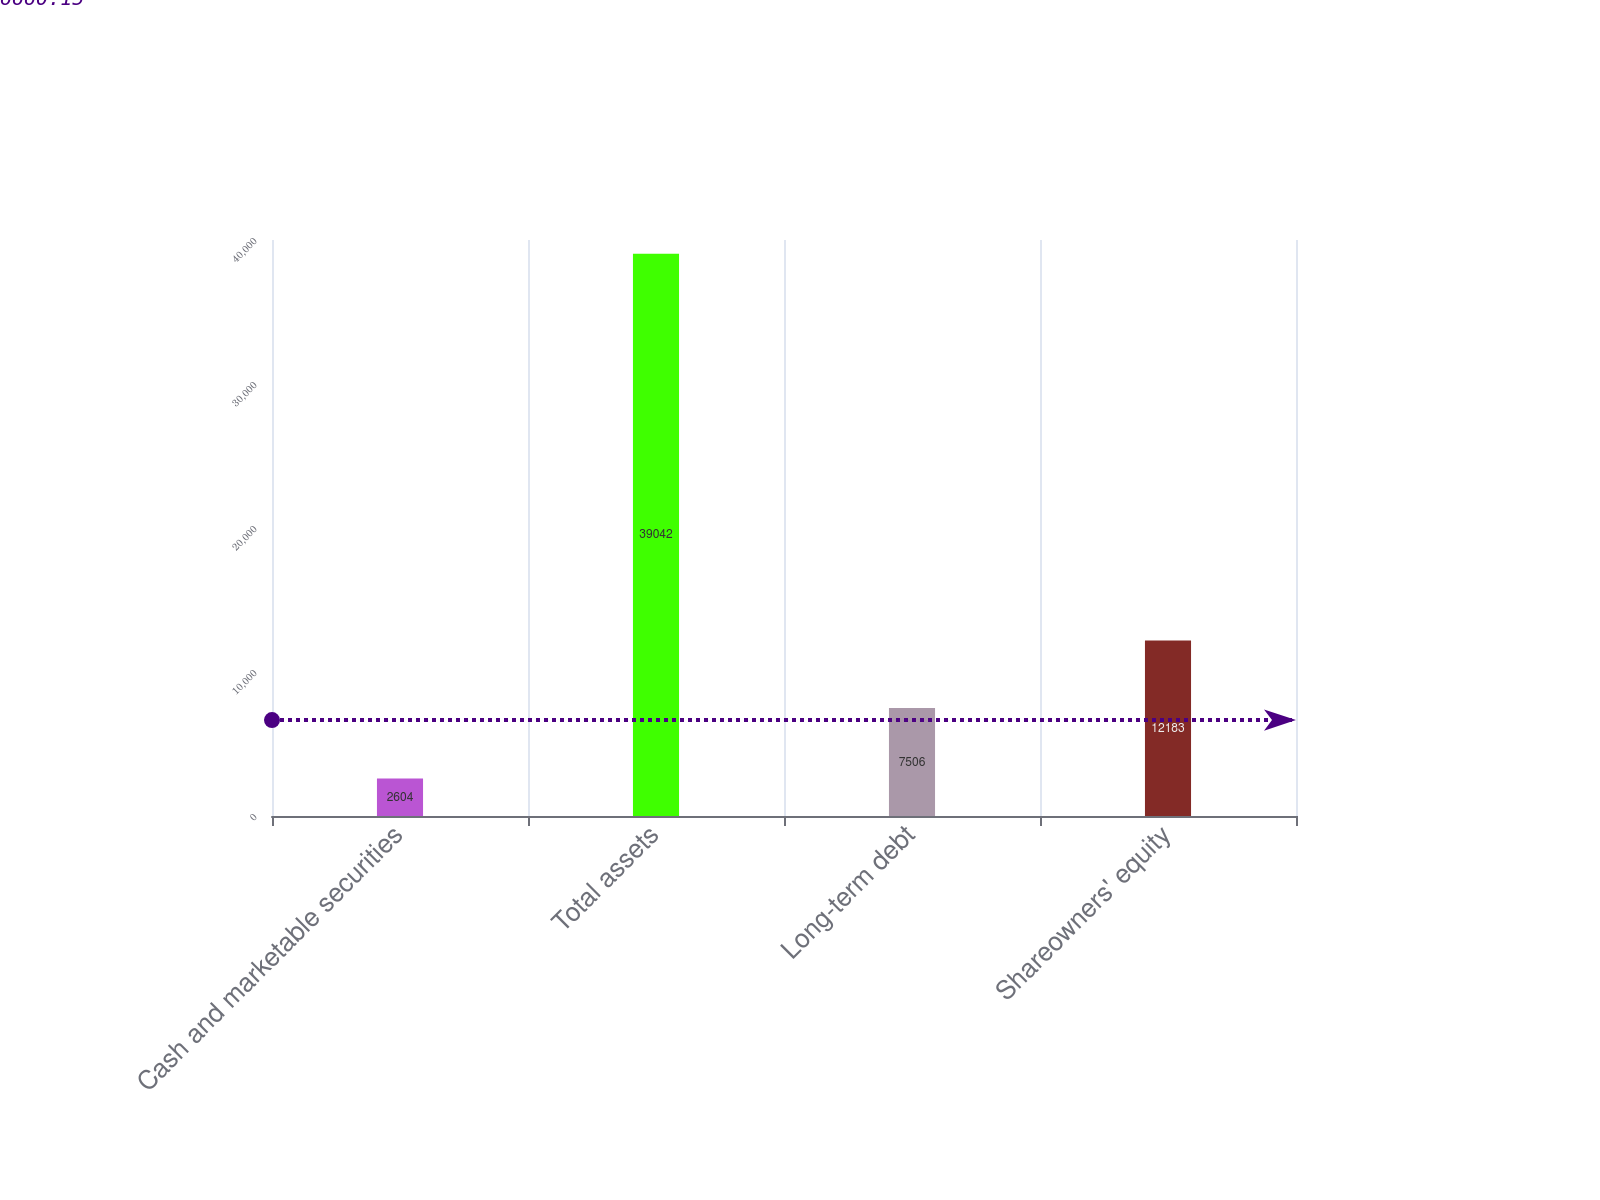Convert chart to OTSL. <chart><loc_0><loc_0><loc_500><loc_500><bar_chart><fcel>Cash and marketable securities<fcel>Total assets<fcel>Long-term debt<fcel>Shareowners' equity<nl><fcel>2604<fcel>39042<fcel>7506<fcel>12183<nl></chart> 